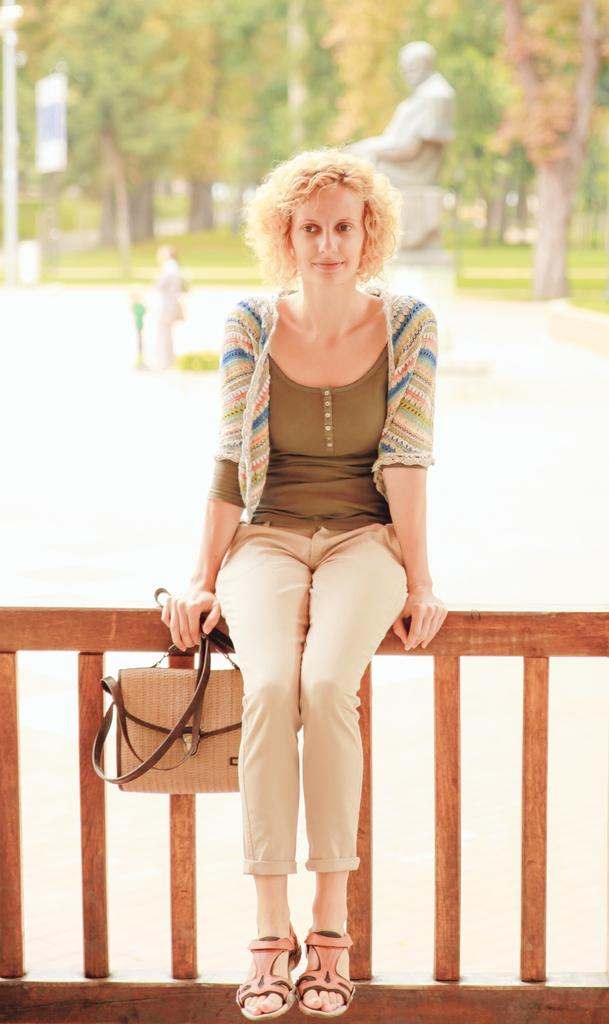Who is the main subject in the foreground of the image? There is a woman in the foreground of the image. What is the woman holding in the image? The woman is holding a bag. Where is the woman sitting in the image? The woman is sitting on a wooden railing. What can be seen in the background of the image? There is a statue, a person, and trees in the background of the image. What type of tray is being used by the mist in the image? There is no mist or tray present in the image. 